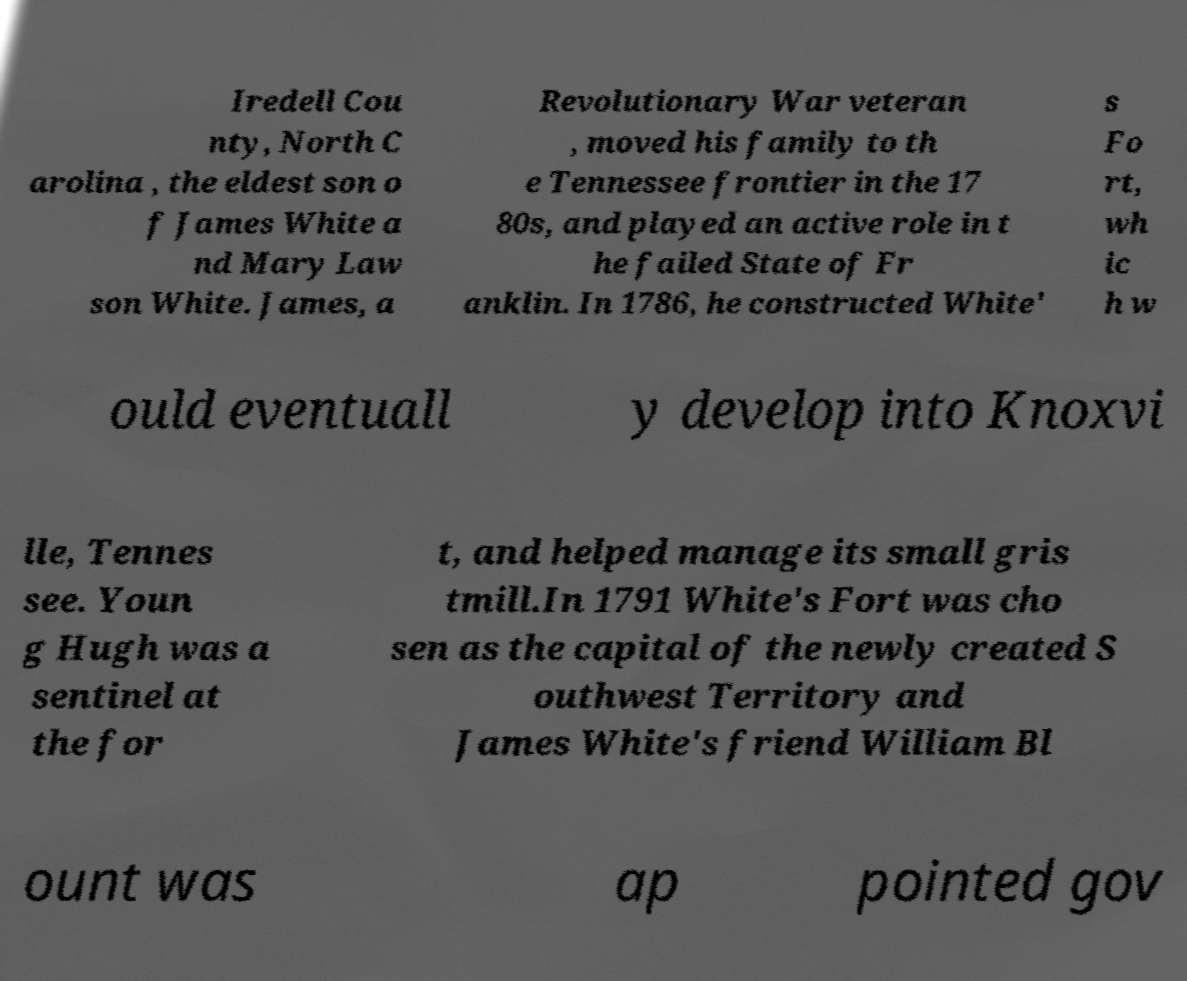Can you read and provide the text displayed in the image?This photo seems to have some interesting text. Can you extract and type it out for me? Iredell Cou nty, North C arolina , the eldest son o f James White a nd Mary Law son White. James, a Revolutionary War veteran , moved his family to th e Tennessee frontier in the 17 80s, and played an active role in t he failed State of Fr anklin. In 1786, he constructed White' s Fo rt, wh ic h w ould eventuall y develop into Knoxvi lle, Tennes see. Youn g Hugh was a sentinel at the for t, and helped manage its small gris tmill.In 1791 White's Fort was cho sen as the capital of the newly created S outhwest Territory and James White's friend William Bl ount was ap pointed gov 